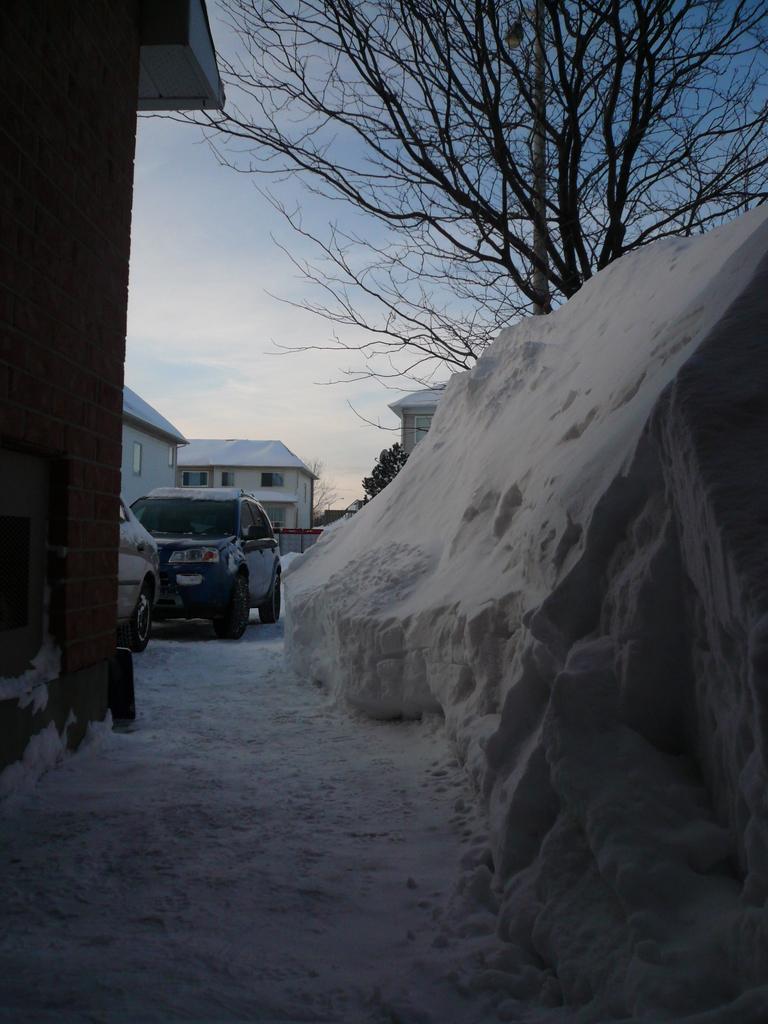Can you describe this image briefly? In this image we can see snow, cars, houses, trees, sky and clouds. 